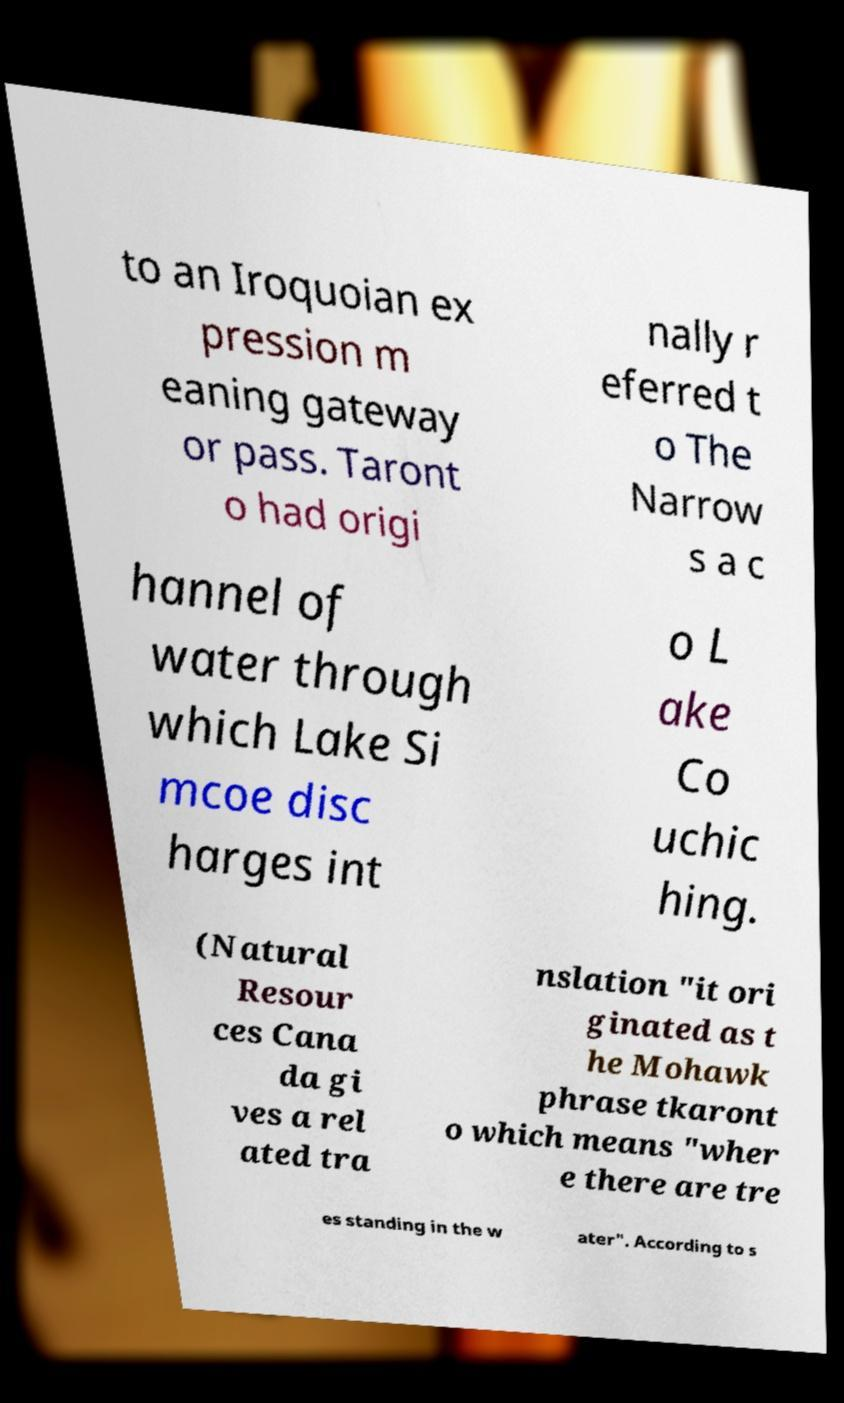Could you extract and type out the text from this image? to an Iroquoian ex pression m eaning gateway or pass. Taront o had origi nally r eferred t o The Narrow s a c hannel of water through which Lake Si mcoe disc harges int o L ake Co uchic hing. (Natural Resour ces Cana da gi ves a rel ated tra nslation "it ori ginated as t he Mohawk phrase tkaront o which means "wher e there are tre es standing in the w ater". According to s 